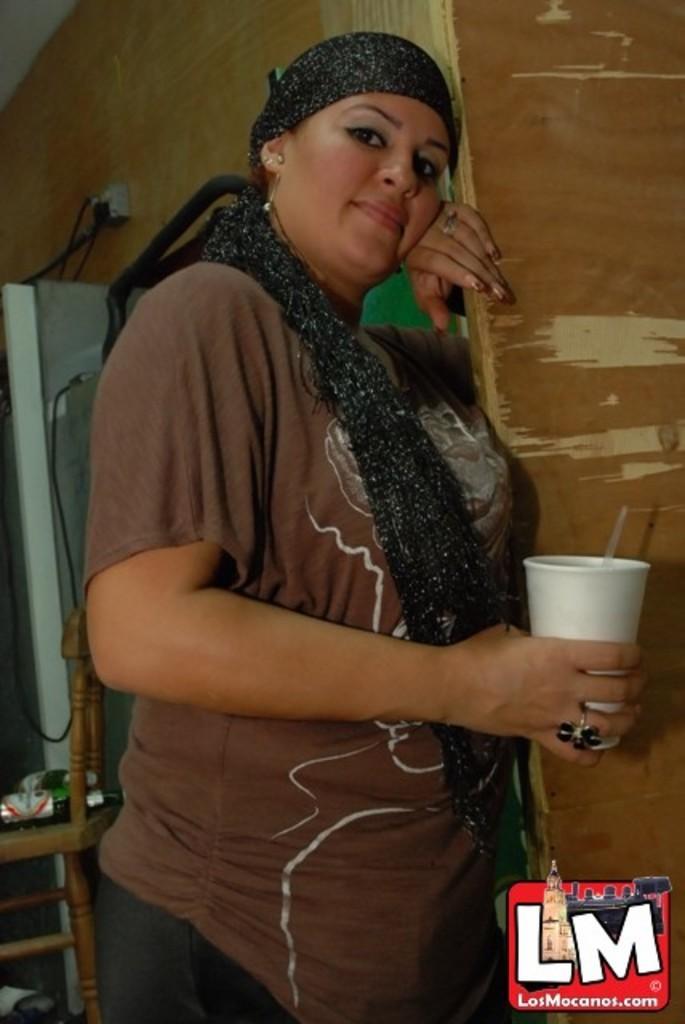Could you give a brief overview of what you see in this image? In the center of the image we can see a lady standing and holding a glass. On the left there is a chair and we can see bottles placed on the chair. In the background there is a wall and we can see wires. 